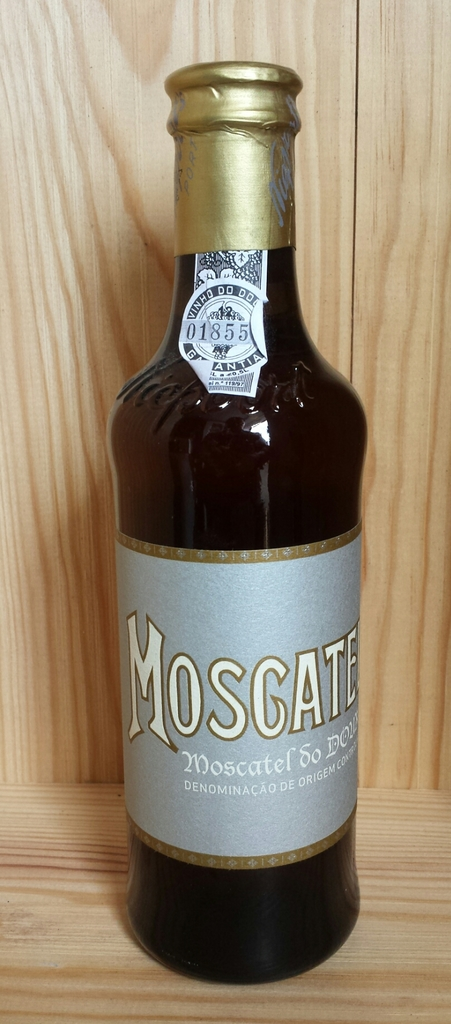What is the significance of the 'Denominação de Origem Controlada' label on this bottle of Moscatel? The 'Denominação de Origem Controlada' (DOC) label on the Moscatel bottle indicates that it was produced in a specific region according to strict regulations, which are designed to assure the wine's quality and authenticity. This status is highly respected and sought after in the wine industry. 